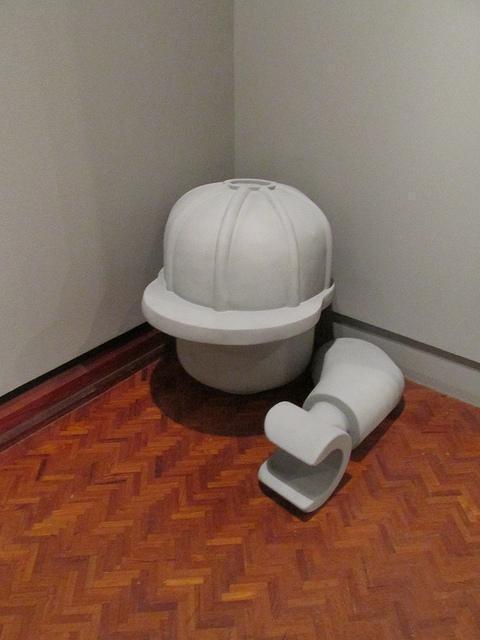How many items are on the wall?
Give a very brief answer. 0. 